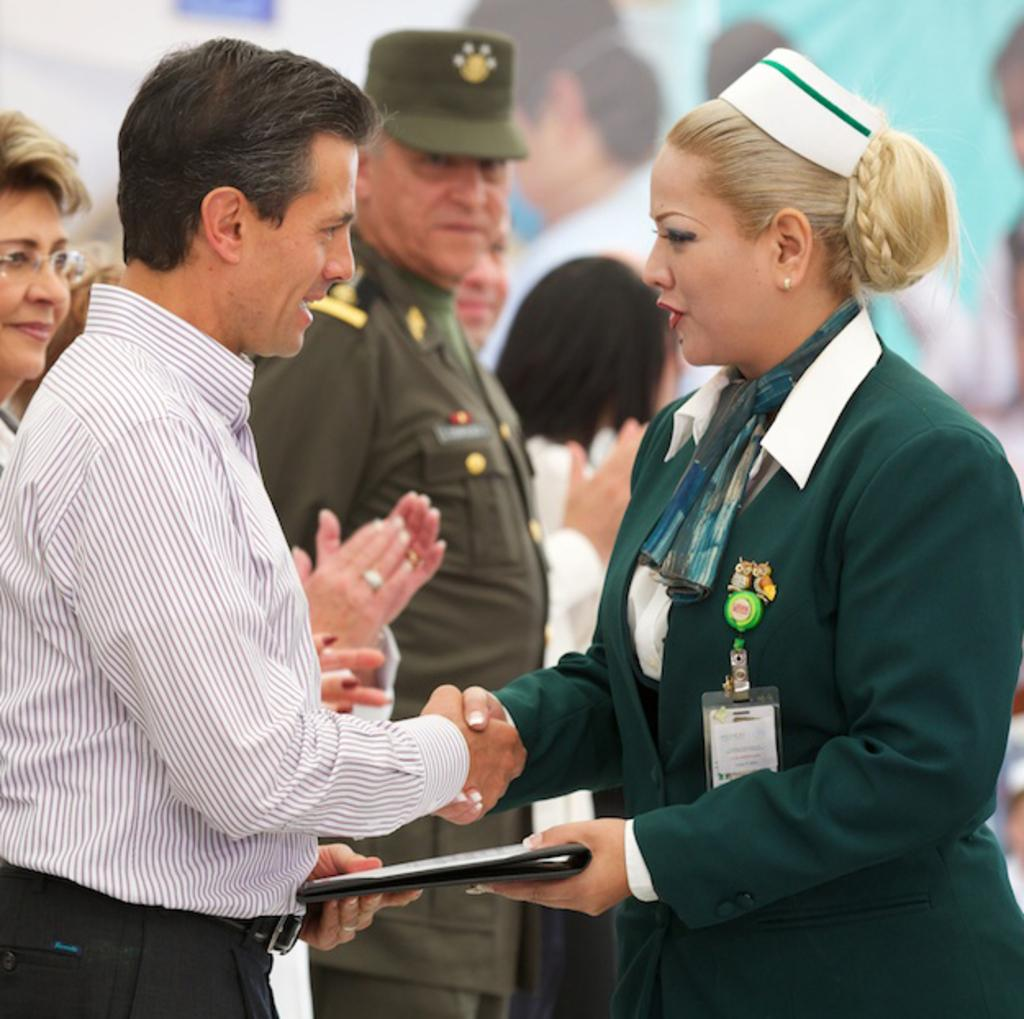Who are the two people in the image? There is a man and a woman in the image. What are the man and woman holding in the image? The man and woman are holding a file. What can be seen in the background of the image? There is a group of people standing in the background of the image, and there is a banner with pictures on it. What type of mountain is visible in the background of the image? There is no mountain visible in the background of the image. What is the name of the memory card used to capture the image? The facts provided do not give any information about the memory card or its name. 